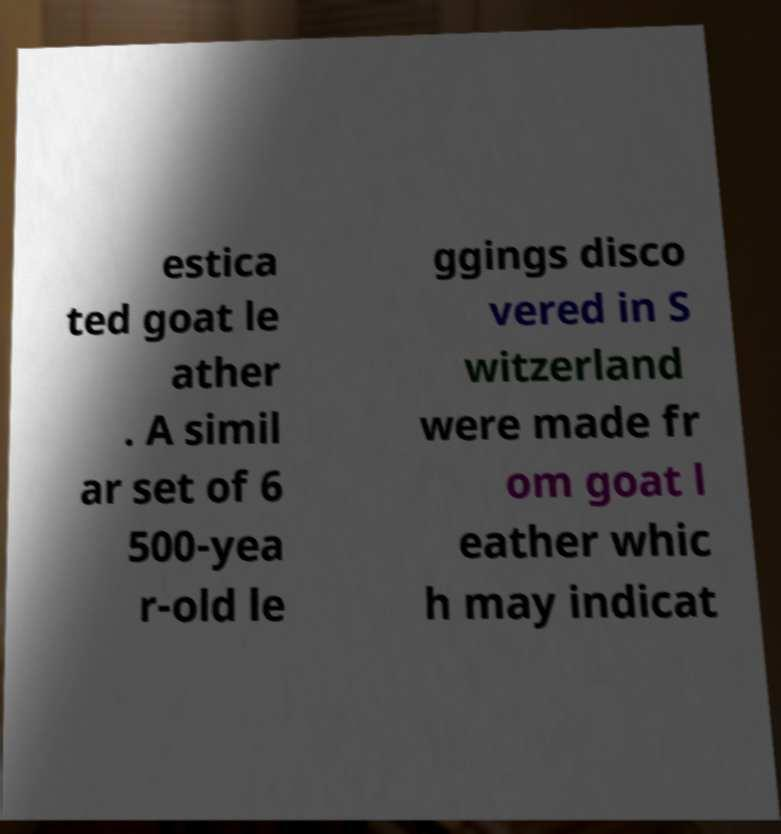I need the written content from this picture converted into text. Can you do that? estica ted goat le ather . A simil ar set of 6 500-yea r-old le ggings disco vered in S witzerland were made fr om goat l eather whic h may indicat 